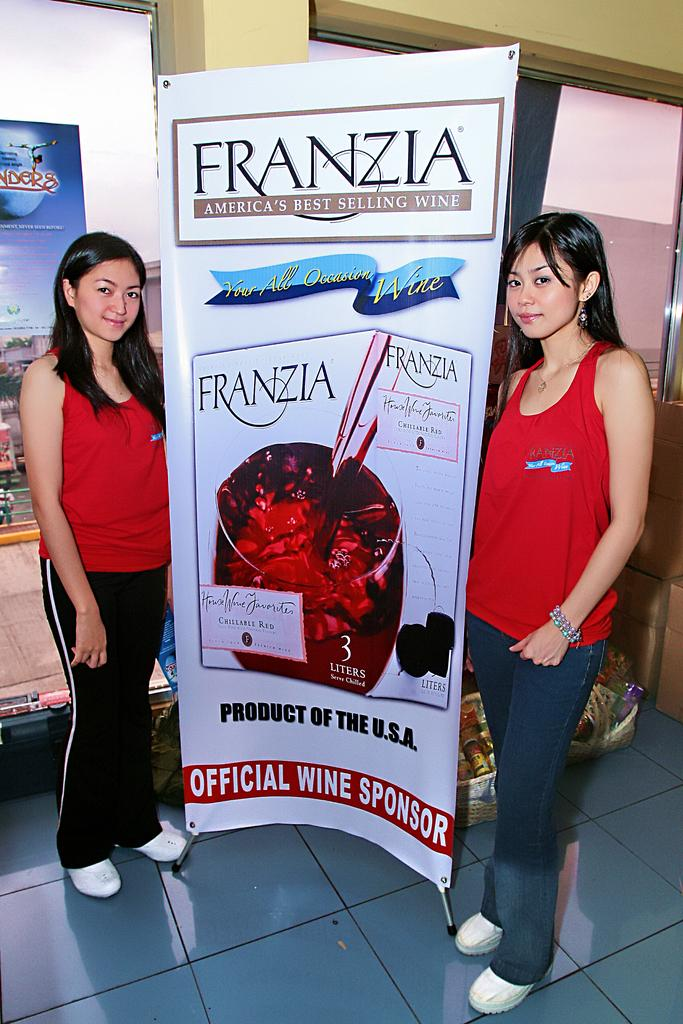How many people are in the image? There are two women in the image. What are the women doing in the image? The women are standing beside a poster. What does the poster say? The poster has text stating "Franzia Americas best selling wine." What can be seen in the background of the image? There is a glass window in the background of the image. What type of ornament is hanging from the glass window in the image? There is no ornament hanging from the glass window in the image. What is the condition of the weather during the rainstorm in the image? There is no rainstorm present in the image; it is an indoor scene with a glass window in the background. 